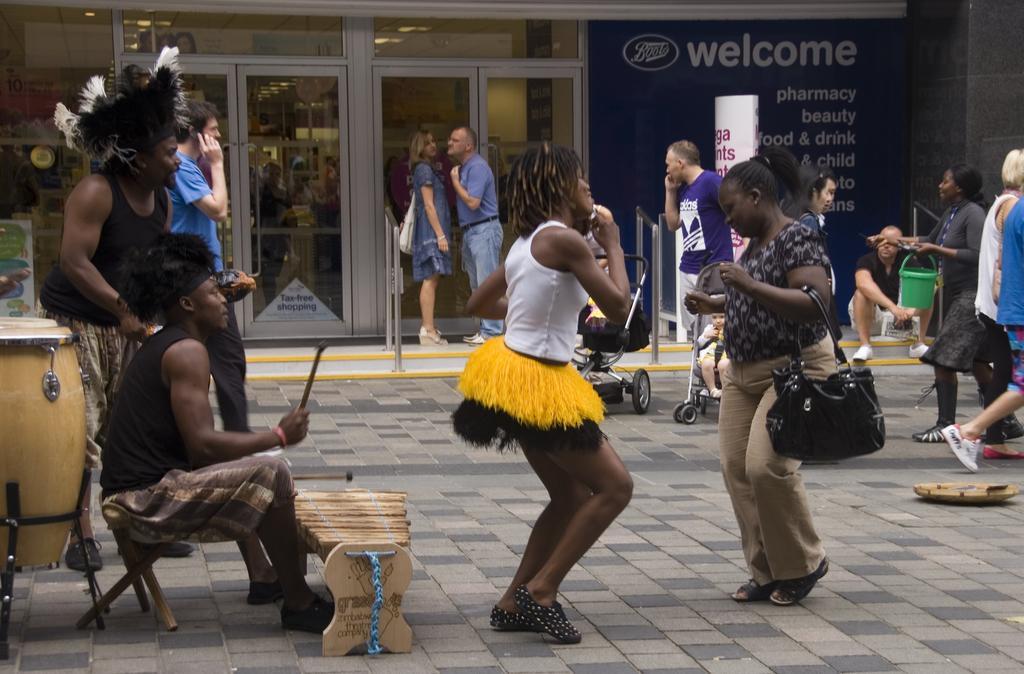Describe this image in one or two sentences. In this picture of group of people dancing here and standing in the background 